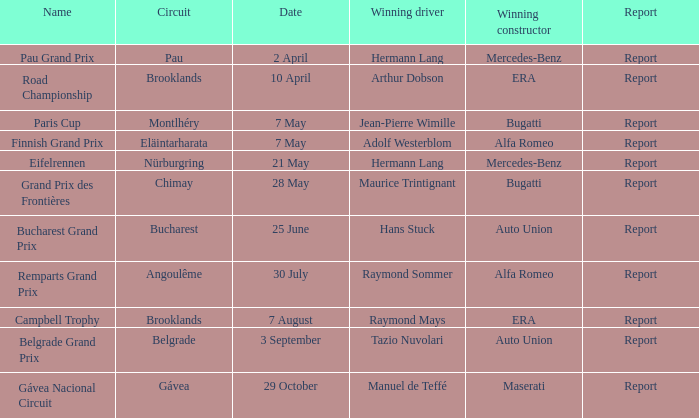Present the update for 30 july. Report. 